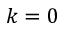<formula> <loc_0><loc_0><loc_500><loc_500>k = 0</formula> 